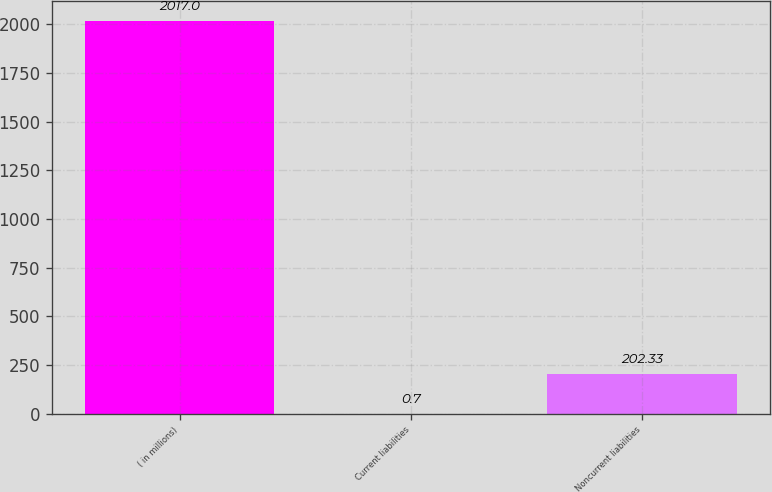Convert chart to OTSL. <chart><loc_0><loc_0><loc_500><loc_500><bar_chart><fcel>( in millions)<fcel>Current liabilities<fcel>Noncurrent liabilities<nl><fcel>2017<fcel>0.7<fcel>202.33<nl></chart> 